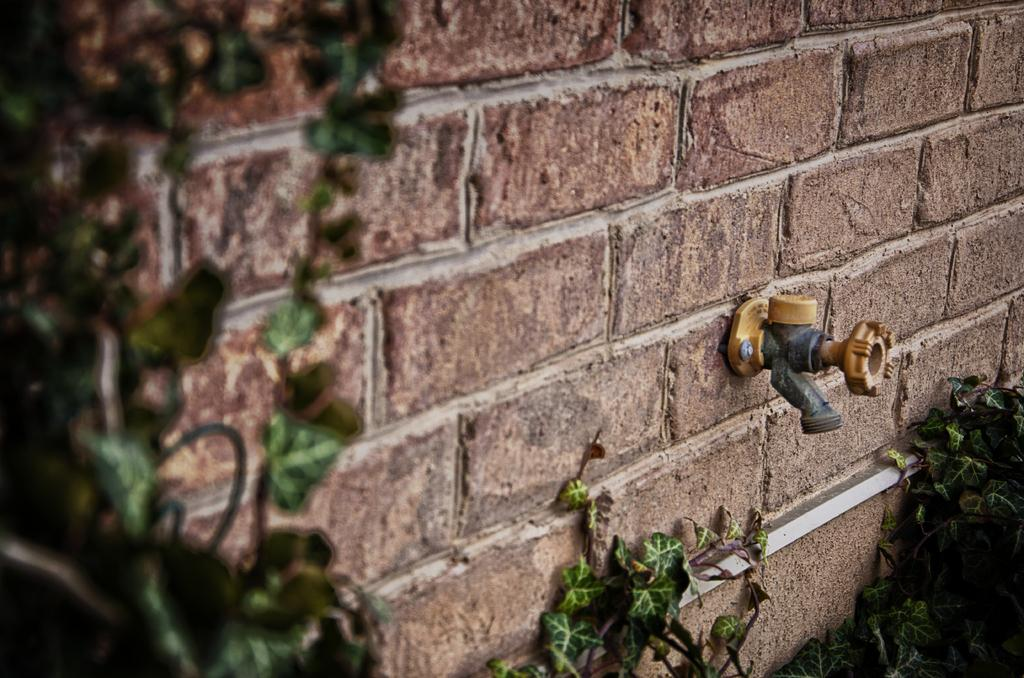What type of vegetation is visible in the front of the image? There are leaves in the front of the image. What can be seen on the wall in the center of the image? There is a tap on the wall in the center of the image. What flavor of paper is being used in the image? There is no paper present in the image, so it is not possible to determine the flavor of any paper. 